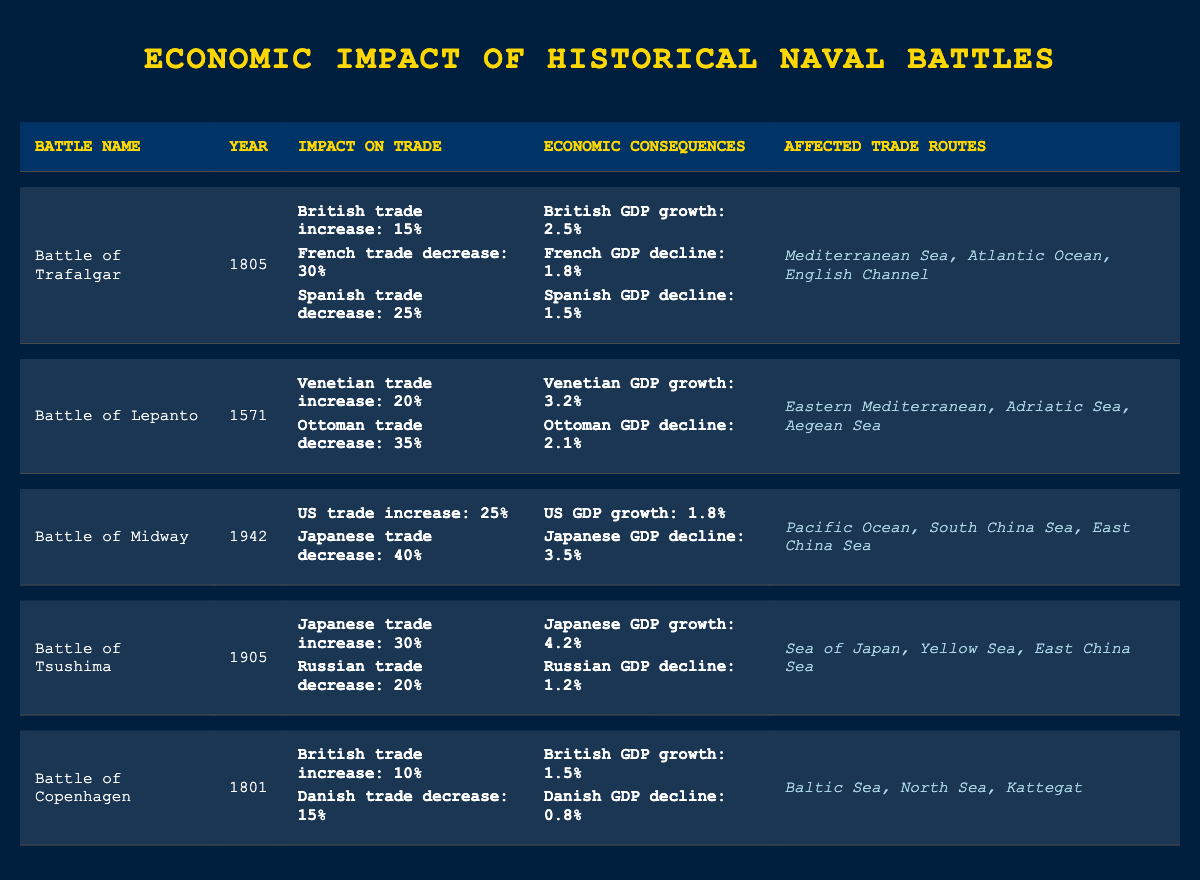What was the impact on British trade after the Battle of Trafalgar? The table states that British trade experienced a 15% increase after the Battle of Trafalgar in 1805.
Answer: 15% Did the Battle of Midway lead to an increase in Japanese trade? According to the table, Japanese trade decreased by 40% after the Battle of Midway in 1942, indicating that it did not lead to an increase.
Answer: No What is the total GDP decline percentage for France and Spain after the Battle of Trafalgar? From the table, French GDP declined by 1.8% and Spanish GDP declined by 1.5%. Adding these gives a total decline of (1.8 + 1.5) = 3.3%.
Answer: 3.3% Which naval battle had the highest increase in GDP for any nation? The table shows that the Battle of Tsushima resulted in a Japanese GDP growth of 4.2%, which is the highest among all battles listed.
Answer: 4.2% Is it true that the affected trade routes of the Battle of Lepanto include the Adriatic Sea? The table clearly states that one of the affected routes is the Adriatic Sea, indicating that this statement is true.
Answer: Yes What was the average trade impact on the British trade across both the Battle of Trafalgar and the Battle of Copenhagen? The British trade increased by 15% from Trafalgar and 10% from Copenhagen. The average can be calculated as (15 + 10) / 2 = 12.5%.
Answer: 12.5% Which battle resulted in the lowest decline in GDP for any nation? By reviewing the table, the least decline is seen in Danish GDP after the Battle of Copenhagen, which is a decline of 0.8%.
Answer: 0.8% After the Battle of Tsushima, what was the combined percentage increase in trade for Japan? Japan's trade increased by 30% after the Battle of Tsushima, making it the only increase represented for this battle. Thus, there is no need for combination as only Japan is relevant for this battle.
Answer: 30% 